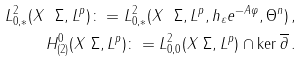Convert formula to latex. <formula><loc_0><loc_0><loc_500><loc_500>L ^ { 2 } _ { 0 , * } ( X \ \Sigma , L ^ { p } ) \colon = L ^ { 2 } _ { 0 , * } ( X \ \Sigma , L ^ { p } , h _ { \varepsilon } e ^ { - A \varphi } , \Theta ^ { n } ) \, , \\ H ^ { 0 } _ { ( 2 ) } ( X \ \Sigma , L ^ { p } ) \colon = L ^ { 2 } _ { 0 , 0 } ( X \ \Sigma , L ^ { p } ) \cap \ker \overline { \partial } \, .</formula> 